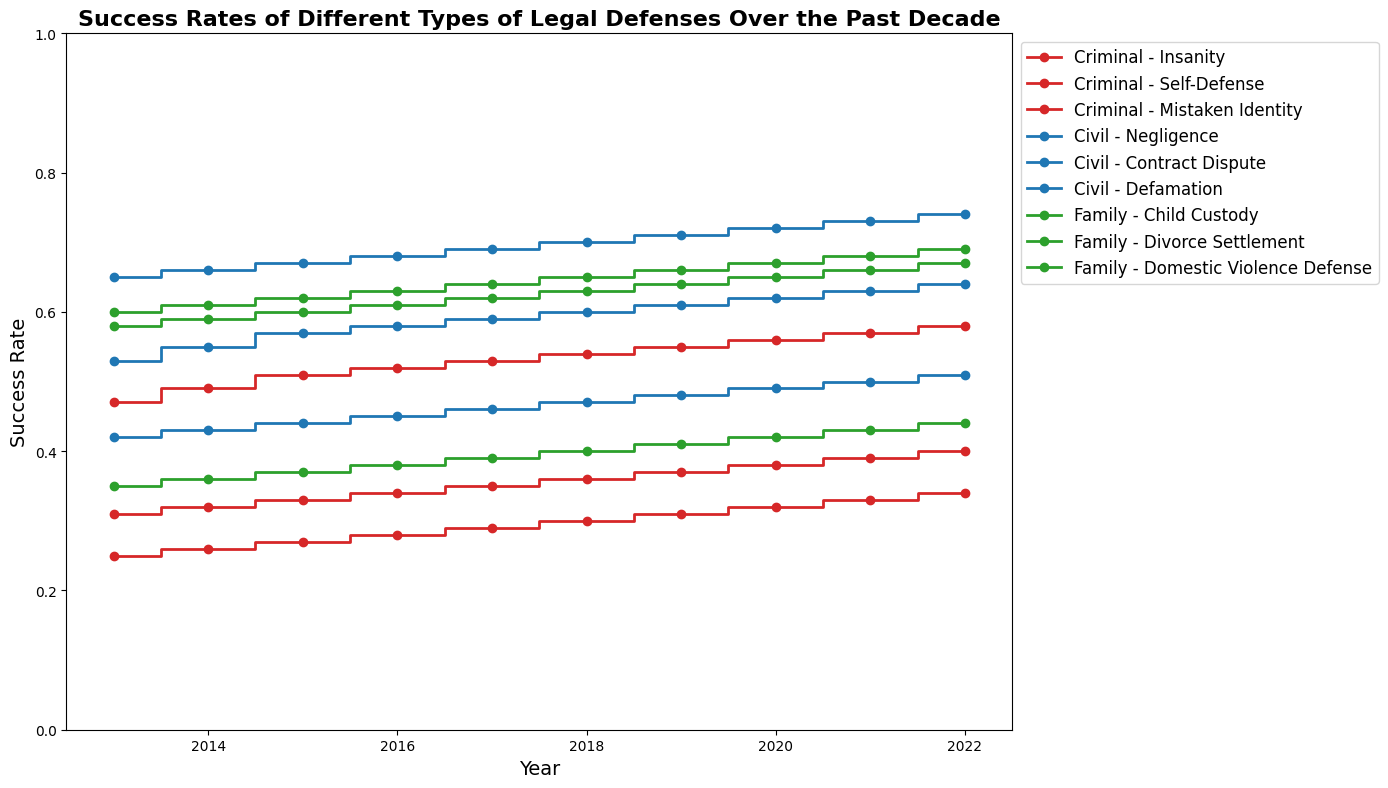What is the trend of the success rate for criminal cases using the Insanity defense over the years? The success rate for the Insanity defense in criminal cases shows a gradual increase from 0.25 in 2013 to 0.34 in 2022.
Answer: Gradual increase Which defense type in criminal cases had the highest success rate in 2015? In 2015, the success rate for Self-Defense in criminal cases was 0.51, which is higher than Insanity (0.27) and Mistaken Identity (0.33).
Answer: Self-Defense How did the success rate of Civil Contract Dispute defenses change from 2013 to 2022? The success rate for Civil Contract Dispute defenses increased from 0.53 in 2013 to 0.64 in 2022, showing a steady upward trend.
Answer: Increased Compare the success rates of Child Custody defenses and Divorce Settlement defenses in 2022. Which one is higher? In 2022, the success rate of Child Custody defenses is 0.67, while the success rate of Divorce Settlement defenses is 0.69. Therefore, Divorce Settlement defenses have a slightly higher success rate.
Answer: Divorce Settlement defenses What is the average success rate for criminal cases with the Mistaken Identity defense between 2013 and 2022? The success rates for Mistaken Identity from 2013 to 2022 are: 0.31, 0.32, 0.33, 0.34, 0.35, 0.36, 0.37, 0.38, 0.39, 0.40. Summing these rates gives 3.55. The average is 3.55/10 = 0.355.
Answer: 0.355 Which legal defense type in family cases maintained the most stable success rate over the past decade? Child Custody defenses had the most stable success rates in family cases, increasing from 0.58 in 2013 to 0.67 in 2022 with consistent annual increases.
Answer: Child Custody defenses In which year did Civil Negligence defenses have the highest success rate, and what was it? Civil Negligence defenses had the highest success rate of 0.74 in 2022.
Answer: 2022 and 0.74 Considering Family cases, which defense had the lowest success rate in 2020, and what was this rate? In 2020, the Domestic Violence Defense had the lowest success rate in Family cases at 0.42.
Answer: Domestic Violence Defense and 0.42 What is the difference in the success rates between Civil Defamation defenses and Criminal Self-Defense in 2013? In 2013, the success rate for Civil Defamation defenses was 0.42, and for Criminal Self-Defense, it was 0.47. The difference is 0.47 - 0.42 = 0.05.
Answer: 0.05 What was the success rate trend of Divorce Settlement defenses in family cases from 2013 to 2017? The success rate for Divorce Settlement defenses in family cases shows an increasing trend from 0.60 in 2013 to 0.64 in 2017.
Answer: Increasing trend 